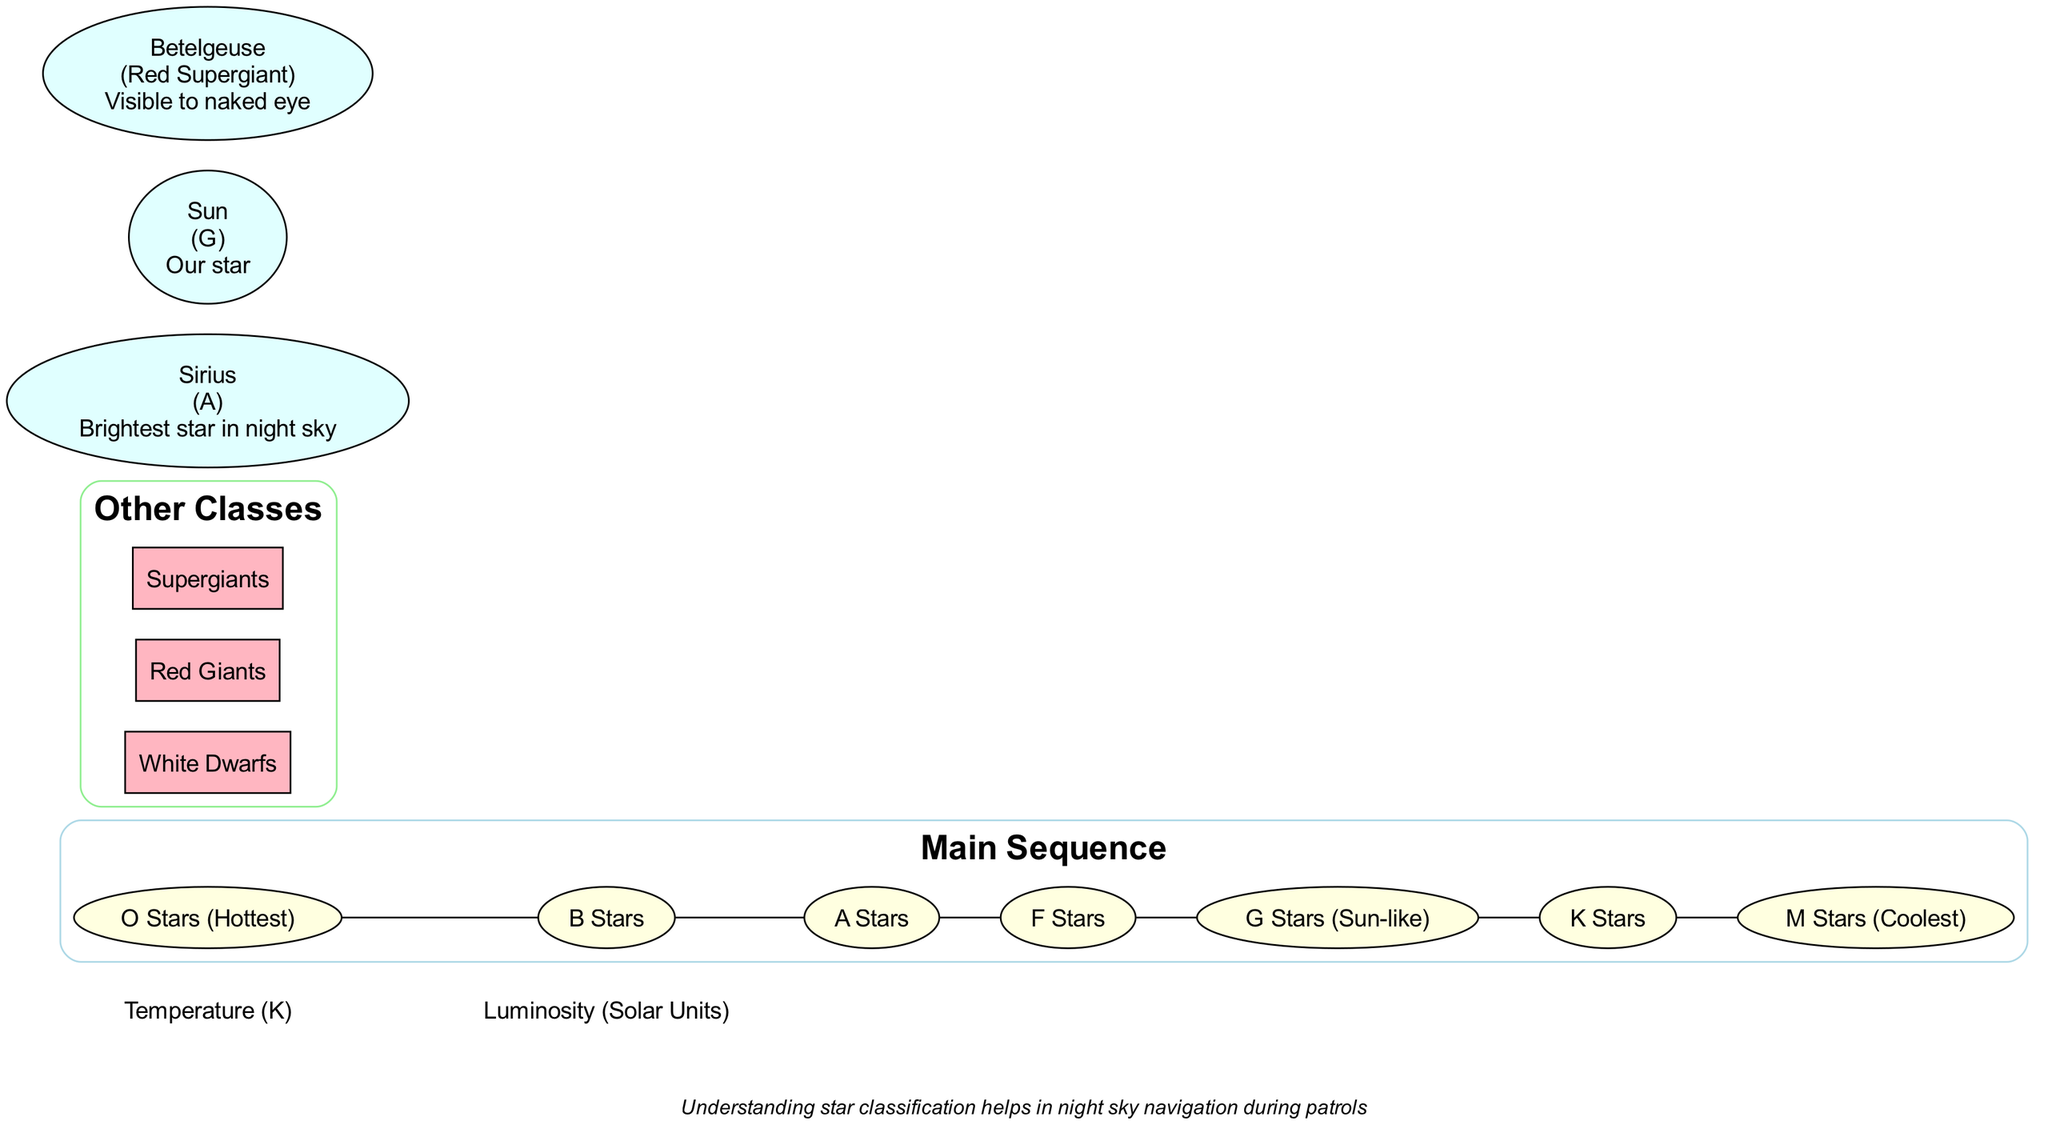What is the hottest class of stars in the main sequence? The hottest class is labeled as "O Stars" in the diagram. This can be directly identified in the main sequence section where classes are listed from hottest to coolest.
Answer: O Stars How many main sequence star classes are there? The diagram displays seven main sequence star classes listed under "Main Sequence." By counting the items from "O Stars" to "M Stars," I confirm that there are seven classes.
Answer: 7 What is the class of the Sun? The diagram indicates that the Sun is categorized as a "G" class star. This information is found in the examples section where the Sun's classification is explicitly mentioned.
Answer: G Which star is described as the brightest star in the night sky? According to the examples section in the diagram, "Sirius" is noted as the brightest star in the night sky. This is explicitly stated in its description in the diagram.
Answer: Sirius What are two examples of stars listed under other classes? The diagram lists various classes under "Other Classes." Two examples taken from this section are "White Dwarfs" and "Red Giants," directly identifiable in the specified classification portion.
Answer: White Dwarfs, Red Giants Which star class is associated with Betelgeuse? The diagram classifies Betelgeuse as a "Red Supergiant." This classification can be found in the examples section where it provides the details of Betelgeuse's characteristics.
Answer: Red Supergiant Which class of stars is considered Sun-like? The diagram explicitly classifies "G Stars" as Sun-like under the main sequence section. This is confirmed by directly checking the classification list present.
Answer: G Stars Are Supergiants listed in the main sequence? No, Supergiants are classified under "Other Classes" within the diagram. This can be verified by examining both the main sequence and other classes sections, finding that Supergiants are not part of the main sequence.
Answer: No 